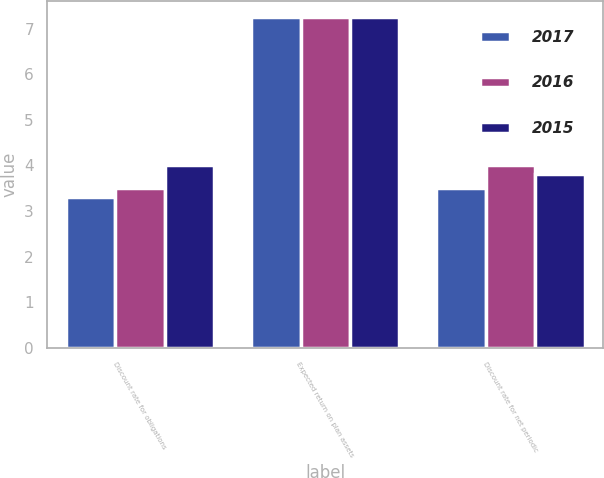Convert chart to OTSL. <chart><loc_0><loc_0><loc_500><loc_500><stacked_bar_chart><ecel><fcel>Discount rate for obligations<fcel>Expected return on plan assets<fcel>Discount rate for net periodic<nl><fcel>2017<fcel>3.3<fcel>7.25<fcel>3.5<nl><fcel>2016<fcel>3.5<fcel>7.25<fcel>4<nl><fcel>2015<fcel>4<fcel>7.25<fcel>3.8<nl></chart> 